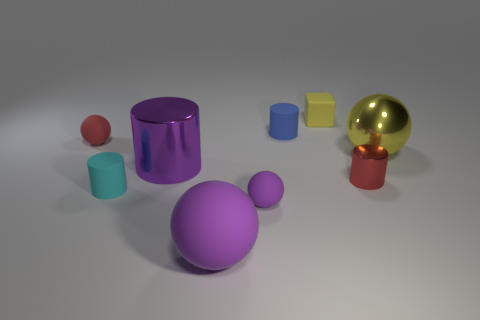Subtract 1 spheres. How many spheres are left? 3 Add 1 tiny cyan matte cylinders. How many objects exist? 10 Subtract all cubes. How many objects are left? 8 Subtract 0 green cubes. How many objects are left? 9 Subtract all large metal cylinders. Subtract all small metal cylinders. How many objects are left? 7 Add 7 yellow things. How many yellow things are left? 9 Add 3 large green balls. How many large green balls exist? 3 